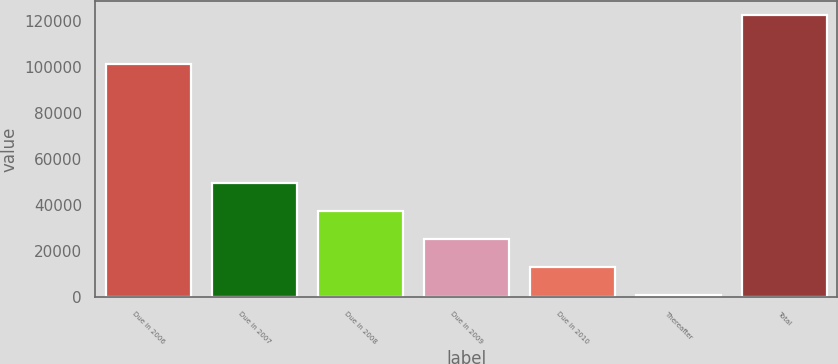Convert chart to OTSL. <chart><loc_0><loc_0><loc_500><loc_500><bar_chart><fcel>Due in 2006<fcel>Due in 2007<fcel>Due in 2008<fcel>Due in 2009<fcel>Due in 2010<fcel>Thereafter<fcel>Total<nl><fcel>101461<fcel>49759.4<fcel>37600.3<fcel>25441.2<fcel>13282.1<fcel>1123<fcel>122714<nl></chart> 